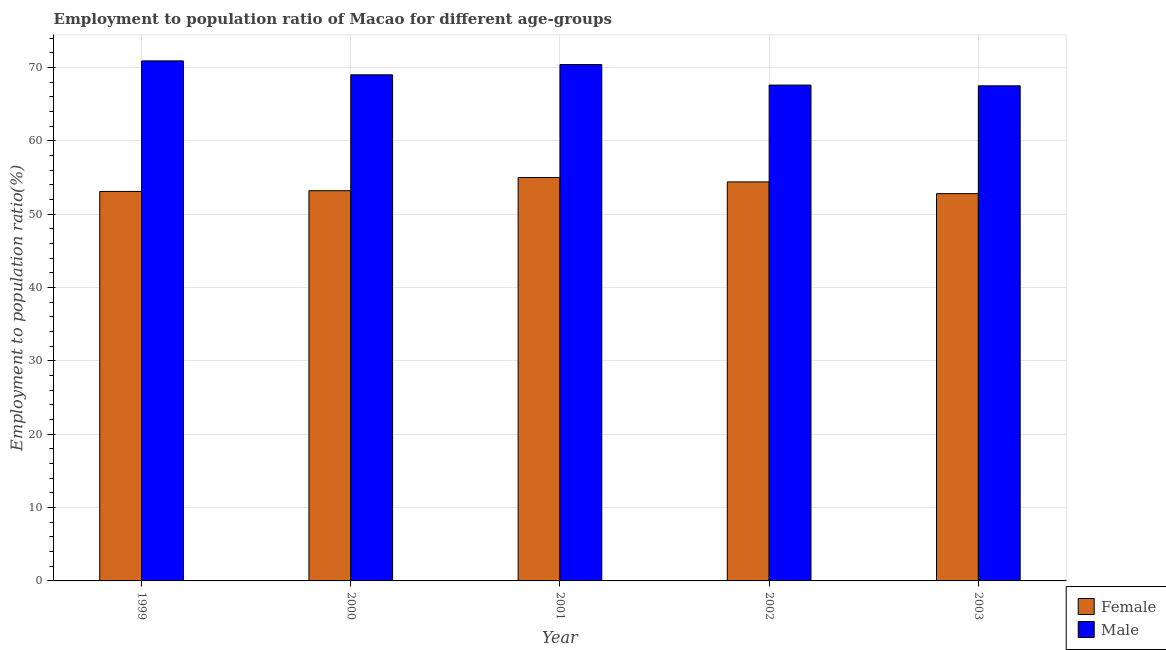How many different coloured bars are there?
Provide a succinct answer. 2. Are the number of bars per tick equal to the number of legend labels?
Your answer should be very brief. Yes. What is the employment to population ratio(male) in 1999?
Offer a terse response. 70.9. Across all years, what is the minimum employment to population ratio(female)?
Your answer should be compact. 52.8. In which year was the employment to population ratio(male) minimum?
Your response must be concise. 2003. What is the total employment to population ratio(female) in the graph?
Your answer should be compact. 268.5. What is the difference between the employment to population ratio(male) in 2001 and that in 2002?
Offer a very short reply. 2.8. What is the difference between the employment to population ratio(female) in 1999 and the employment to population ratio(male) in 2000?
Provide a short and direct response. -0.1. What is the average employment to population ratio(female) per year?
Your response must be concise. 53.7. In how many years, is the employment to population ratio(female) greater than 34 %?
Provide a short and direct response. 5. What is the ratio of the employment to population ratio(male) in 2001 to that in 2003?
Offer a terse response. 1.04. What is the difference between the highest and the second highest employment to population ratio(female)?
Offer a terse response. 0.6. What is the difference between the highest and the lowest employment to population ratio(female)?
Offer a very short reply. 2.2. In how many years, is the employment to population ratio(female) greater than the average employment to population ratio(female) taken over all years?
Offer a very short reply. 2. What does the 1st bar from the right in 2002 represents?
Offer a very short reply. Male. Are all the bars in the graph horizontal?
Offer a terse response. No. How many years are there in the graph?
Your answer should be very brief. 5. Are the values on the major ticks of Y-axis written in scientific E-notation?
Provide a succinct answer. No. Does the graph contain any zero values?
Your response must be concise. No. Does the graph contain grids?
Provide a succinct answer. Yes. Where does the legend appear in the graph?
Give a very brief answer. Bottom right. How many legend labels are there?
Offer a terse response. 2. What is the title of the graph?
Provide a short and direct response. Employment to population ratio of Macao for different age-groups. Does "Young" appear as one of the legend labels in the graph?
Offer a very short reply. No. What is the label or title of the X-axis?
Offer a very short reply. Year. What is the Employment to population ratio(%) of Female in 1999?
Offer a very short reply. 53.1. What is the Employment to population ratio(%) in Male in 1999?
Offer a very short reply. 70.9. What is the Employment to population ratio(%) in Female in 2000?
Ensure brevity in your answer.  53.2. What is the Employment to population ratio(%) of Female in 2001?
Your answer should be compact. 55. What is the Employment to population ratio(%) of Male in 2001?
Provide a succinct answer. 70.4. What is the Employment to population ratio(%) in Female in 2002?
Give a very brief answer. 54.4. What is the Employment to population ratio(%) in Male in 2002?
Provide a short and direct response. 67.6. What is the Employment to population ratio(%) in Female in 2003?
Your answer should be compact. 52.8. What is the Employment to population ratio(%) in Male in 2003?
Provide a short and direct response. 67.5. Across all years, what is the maximum Employment to population ratio(%) in Male?
Keep it short and to the point. 70.9. Across all years, what is the minimum Employment to population ratio(%) of Female?
Keep it short and to the point. 52.8. Across all years, what is the minimum Employment to population ratio(%) of Male?
Your answer should be compact. 67.5. What is the total Employment to population ratio(%) of Female in the graph?
Ensure brevity in your answer.  268.5. What is the total Employment to population ratio(%) of Male in the graph?
Offer a very short reply. 345.4. What is the difference between the Employment to population ratio(%) of Male in 1999 and that in 2000?
Offer a terse response. 1.9. What is the difference between the Employment to population ratio(%) of Female in 1999 and that in 2001?
Give a very brief answer. -1.9. What is the difference between the Employment to population ratio(%) of Male in 1999 and that in 2001?
Your answer should be very brief. 0.5. What is the difference between the Employment to population ratio(%) of Male in 1999 and that in 2002?
Ensure brevity in your answer.  3.3. What is the difference between the Employment to population ratio(%) of Female in 1999 and that in 2003?
Give a very brief answer. 0.3. What is the difference between the Employment to population ratio(%) in Male in 2000 and that in 2002?
Offer a terse response. 1.4. What is the difference between the Employment to population ratio(%) in Female in 2000 and that in 2003?
Make the answer very short. 0.4. What is the difference between the Employment to population ratio(%) in Male in 2000 and that in 2003?
Keep it short and to the point. 1.5. What is the difference between the Employment to population ratio(%) of Male in 2001 and that in 2002?
Offer a very short reply. 2.8. What is the difference between the Employment to population ratio(%) in Female in 1999 and the Employment to population ratio(%) in Male in 2000?
Your answer should be very brief. -15.9. What is the difference between the Employment to population ratio(%) of Female in 1999 and the Employment to population ratio(%) of Male in 2001?
Offer a very short reply. -17.3. What is the difference between the Employment to population ratio(%) in Female in 1999 and the Employment to population ratio(%) in Male in 2002?
Your answer should be very brief. -14.5. What is the difference between the Employment to population ratio(%) in Female in 1999 and the Employment to population ratio(%) in Male in 2003?
Ensure brevity in your answer.  -14.4. What is the difference between the Employment to population ratio(%) in Female in 2000 and the Employment to population ratio(%) in Male in 2001?
Your answer should be compact. -17.2. What is the difference between the Employment to population ratio(%) of Female in 2000 and the Employment to population ratio(%) of Male in 2002?
Your answer should be compact. -14.4. What is the difference between the Employment to population ratio(%) of Female in 2000 and the Employment to population ratio(%) of Male in 2003?
Offer a terse response. -14.3. What is the difference between the Employment to population ratio(%) in Female in 2001 and the Employment to population ratio(%) in Male in 2003?
Provide a succinct answer. -12.5. What is the difference between the Employment to population ratio(%) of Female in 2002 and the Employment to population ratio(%) of Male in 2003?
Your response must be concise. -13.1. What is the average Employment to population ratio(%) in Female per year?
Offer a terse response. 53.7. What is the average Employment to population ratio(%) of Male per year?
Provide a succinct answer. 69.08. In the year 1999, what is the difference between the Employment to population ratio(%) in Female and Employment to population ratio(%) in Male?
Give a very brief answer. -17.8. In the year 2000, what is the difference between the Employment to population ratio(%) in Female and Employment to population ratio(%) in Male?
Ensure brevity in your answer.  -15.8. In the year 2001, what is the difference between the Employment to population ratio(%) in Female and Employment to population ratio(%) in Male?
Keep it short and to the point. -15.4. In the year 2003, what is the difference between the Employment to population ratio(%) of Female and Employment to population ratio(%) of Male?
Your response must be concise. -14.7. What is the ratio of the Employment to population ratio(%) of Female in 1999 to that in 2000?
Your answer should be very brief. 1. What is the ratio of the Employment to population ratio(%) of Male in 1999 to that in 2000?
Your answer should be very brief. 1.03. What is the ratio of the Employment to population ratio(%) of Female in 1999 to that in 2001?
Your response must be concise. 0.97. What is the ratio of the Employment to population ratio(%) in Male in 1999 to that in 2001?
Your answer should be compact. 1.01. What is the ratio of the Employment to population ratio(%) of Female in 1999 to that in 2002?
Give a very brief answer. 0.98. What is the ratio of the Employment to population ratio(%) in Male in 1999 to that in 2002?
Ensure brevity in your answer.  1.05. What is the ratio of the Employment to population ratio(%) in Female in 1999 to that in 2003?
Your answer should be compact. 1.01. What is the ratio of the Employment to population ratio(%) in Male in 1999 to that in 2003?
Your answer should be very brief. 1.05. What is the ratio of the Employment to population ratio(%) of Female in 2000 to that in 2001?
Ensure brevity in your answer.  0.97. What is the ratio of the Employment to population ratio(%) of Male in 2000 to that in 2001?
Keep it short and to the point. 0.98. What is the ratio of the Employment to population ratio(%) in Female in 2000 to that in 2002?
Your response must be concise. 0.98. What is the ratio of the Employment to population ratio(%) in Male in 2000 to that in 2002?
Your answer should be very brief. 1.02. What is the ratio of the Employment to population ratio(%) of Female in 2000 to that in 2003?
Provide a succinct answer. 1.01. What is the ratio of the Employment to population ratio(%) of Male in 2000 to that in 2003?
Your response must be concise. 1.02. What is the ratio of the Employment to population ratio(%) in Female in 2001 to that in 2002?
Make the answer very short. 1.01. What is the ratio of the Employment to population ratio(%) in Male in 2001 to that in 2002?
Give a very brief answer. 1.04. What is the ratio of the Employment to population ratio(%) of Female in 2001 to that in 2003?
Your answer should be compact. 1.04. What is the ratio of the Employment to population ratio(%) of Male in 2001 to that in 2003?
Offer a very short reply. 1.04. What is the ratio of the Employment to population ratio(%) in Female in 2002 to that in 2003?
Ensure brevity in your answer.  1.03. What is the ratio of the Employment to population ratio(%) in Male in 2002 to that in 2003?
Your response must be concise. 1. What is the difference between the highest and the lowest Employment to population ratio(%) in Female?
Provide a short and direct response. 2.2. What is the difference between the highest and the lowest Employment to population ratio(%) of Male?
Make the answer very short. 3.4. 